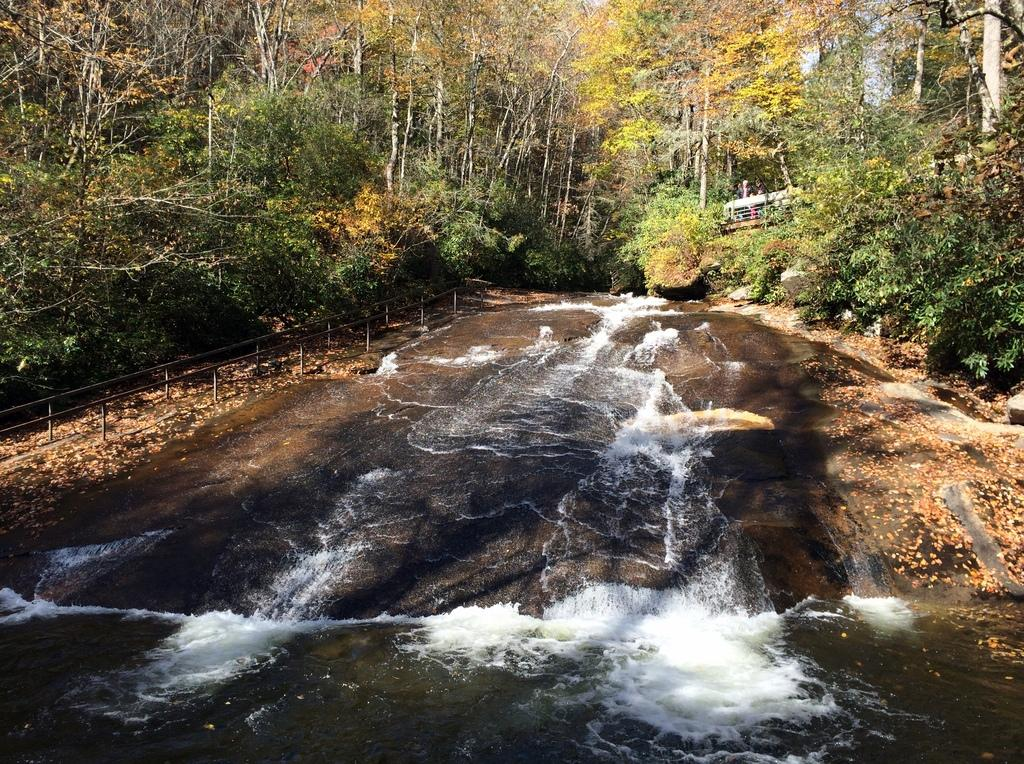What type of vegetation can be seen in the image? There are trees in the image. Where are the metal railings located in the image? There is a metal railing in the left corner and another in the right corner of the image. What is visible at the bottom of the image? There is water visible at the bottom of the image. What is visible at the top of the image? There is sky visible at the top of the image. What type of wood can be seen in the bedroom in the image? There is no bedroom or wood present in the image; it features trees, metal railings, water, and sky. 